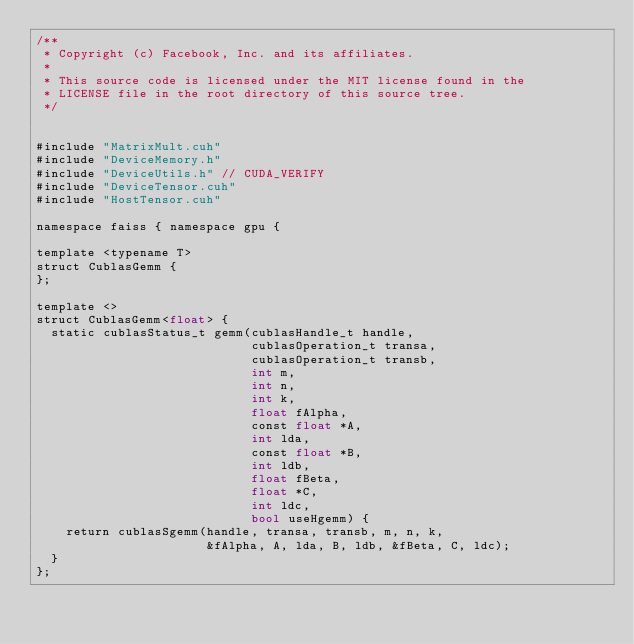Convert code to text. <code><loc_0><loc_0><loc_500><loc_500><_Cuda_>/**
 * Copyright (c) Facebook, Inc. and its affiliates.
 *
 * This source code is licensed under the MIT license found in the
 * LICENSE file in the root directory of this source tree.
 */


#include "MatrixMult.cuh"
#include "DeviceMemory.h"
#include "DeviceUtils.h" // CUDA_VERIFY
#include "DeviceTensor.cuh"
#include "HostTensor.cuh"

namespace faiss { namespace gpu {

template <typename T>
struct CublasGemm {
};

template <>
struct CublasGemm<float> {
  static cublasStatus_t gemm(cublasHandle_t handle,
                             cublasOperation_t transa,
                             cublasOperation_t transb,
                             int m,
                             int n,
                             int k,
                             float fAlpha,
                             const float *A,
                             int lda,
                             const float *B,
                             int ldb,
                             float fBeta,
                             float *C,
                             int ldc,
                             bool useHgemm) {
    return cublasSgemm(handle, transa, transb, m, n, k,
                       &fAlpha, A, lda, B, ldb, &fBeta, C, ldc);
  }
};
</code> 